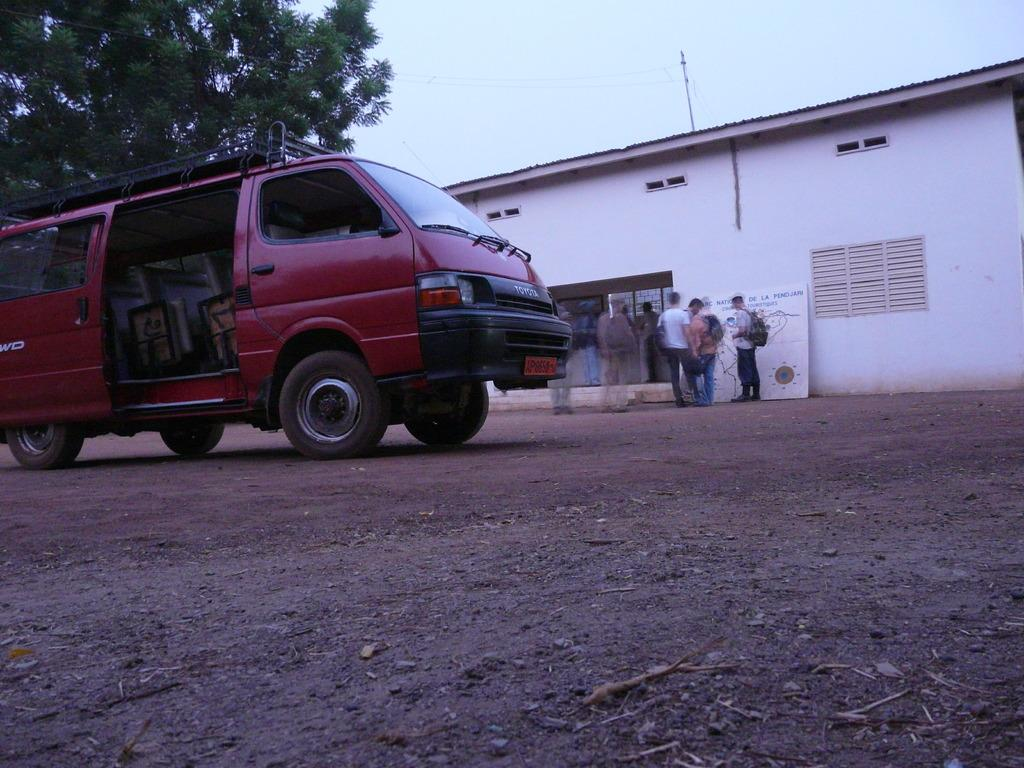What type of vehicle is on the road in the image? There is a van on the road in the image. What structure can be seen in the image? There is a building in the image. What are the people near the building doing? People are standing near the building in the image. What type of plant is visible in the image? There is a tree in the image. What substance is being sprayed from the stage in the image? There is no stage present in the image, so there is no substance being sprayed. What is the cause of death for the person in the image? There is no person in the image, let alone any indication of death. 